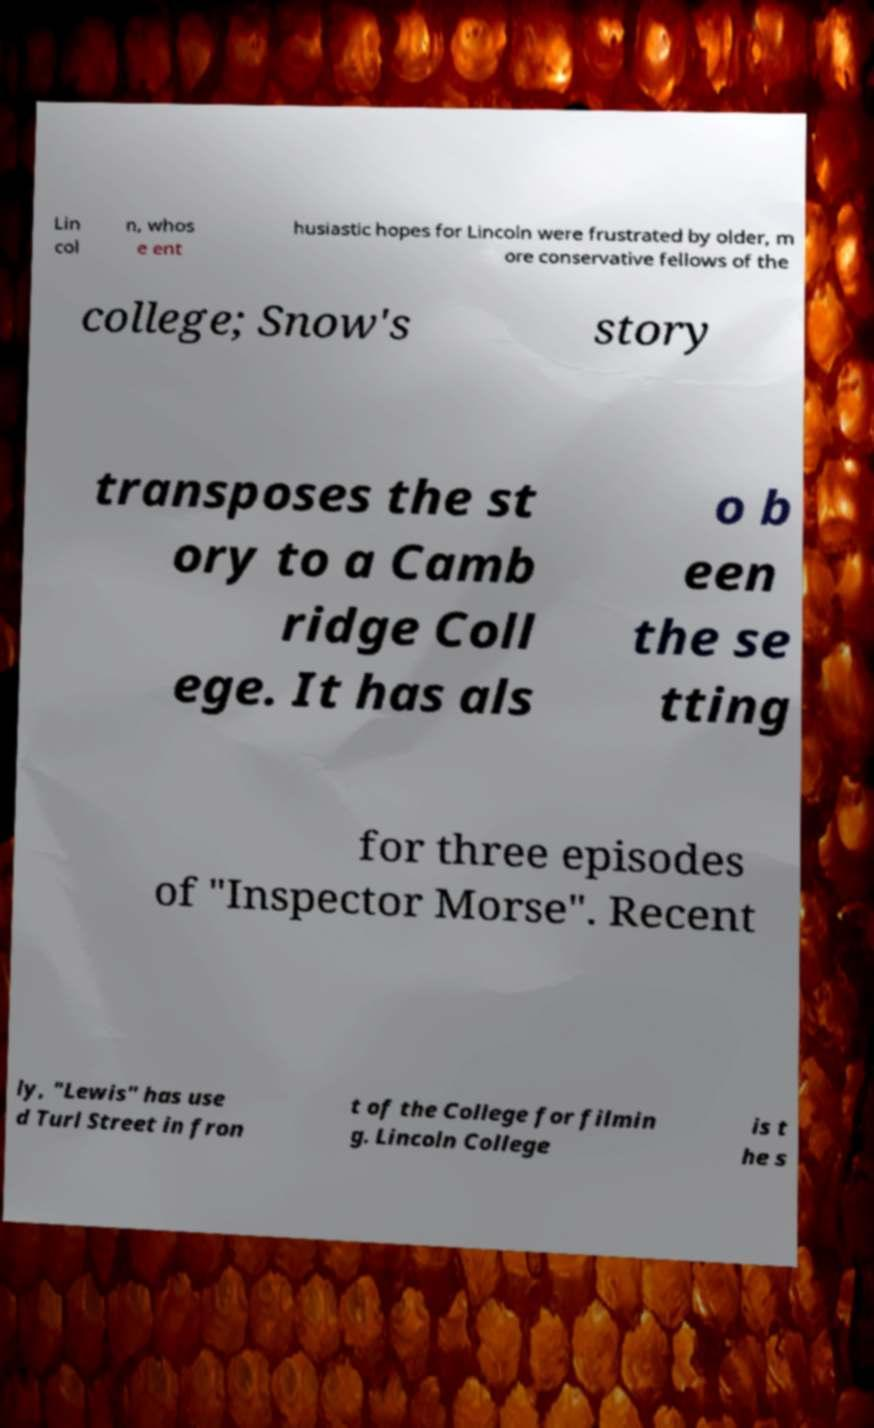Can you accurately transcribe the text from the provided image for me? Lin col n, whos e ent husiastic hopes for Lincoln were frustrated by older, m ore conservative fellows of the college; Snow's story transposes the st ory to a Camb ridge Coll ege. It has als o b een the se tting for three episodes of "Inspector Morse". Recent ly, "Lewis" has use d Turl Street in fron t of the College for filmin g. Lincoln College is t he s 